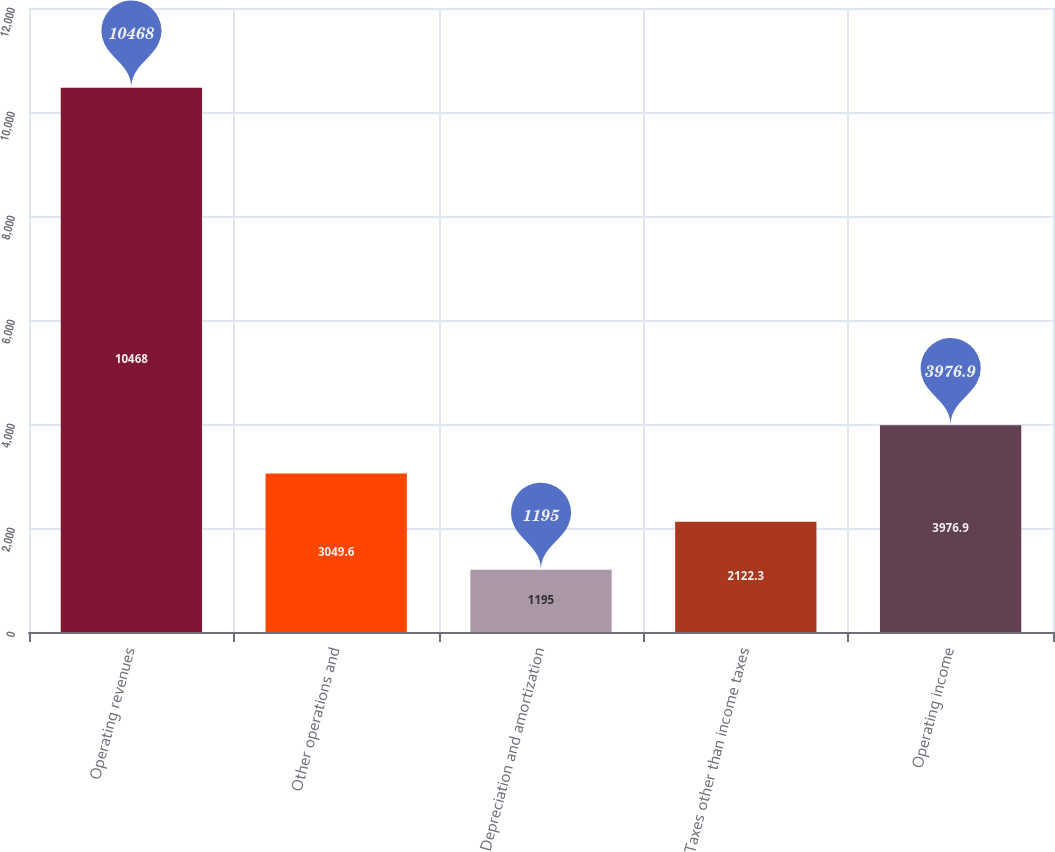<chart> <loc_0><loc_0><loc_500><loc_500><bar_chart><fcel>Operating revenues<fcel>Other operations and<fcel>Depreciation and amortization<fcel>Taxes other than income taxes<fcel>Operating income<nl><fcel>10468<fcel>3049.6<fcel>1195<fcel>2122.3<fcel>3976.9<nl></chart> 